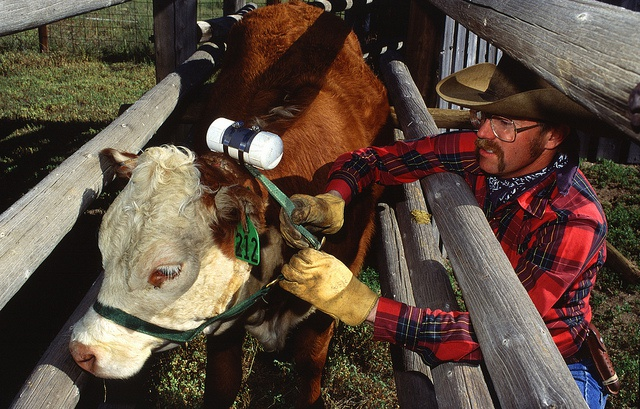Describe the objects in this image and their specific colors. I can see cow in darkgray, black, maroon, and tan tones and people in darkgray, black, maroon, brown, and olive tones in this image. 